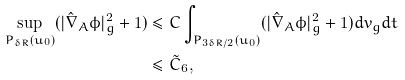<formula> <loc_0><loc_0><loc_500><loc_500>\sup _ { P _ { \delta R } ( u _ { 0 } ) } ( | \hat { \nabla } _ { A } \phi | _ { g } ^ { 2 } + 1 ) & \leq C \int _ { P _ { 3 \delta R / 2 } ( u _ { 0 } ) } ( | \hat { \nabla } _ { A } \phi | _ { g } ^ { 2 } + 1 ) d v _ { g } d t \\ & \leq \tilde { C } _ { 6 } ,</formula> 